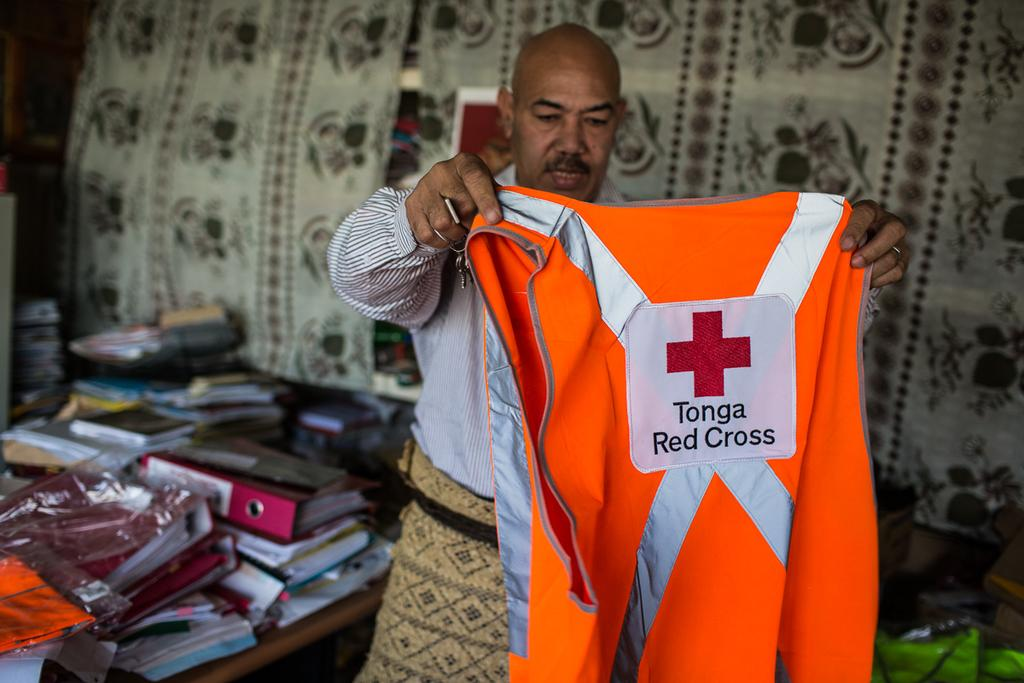<image>
Offer a succinct explanation of the picture presented. A man holds up an orange vest with Tonga Red Cross on the back 